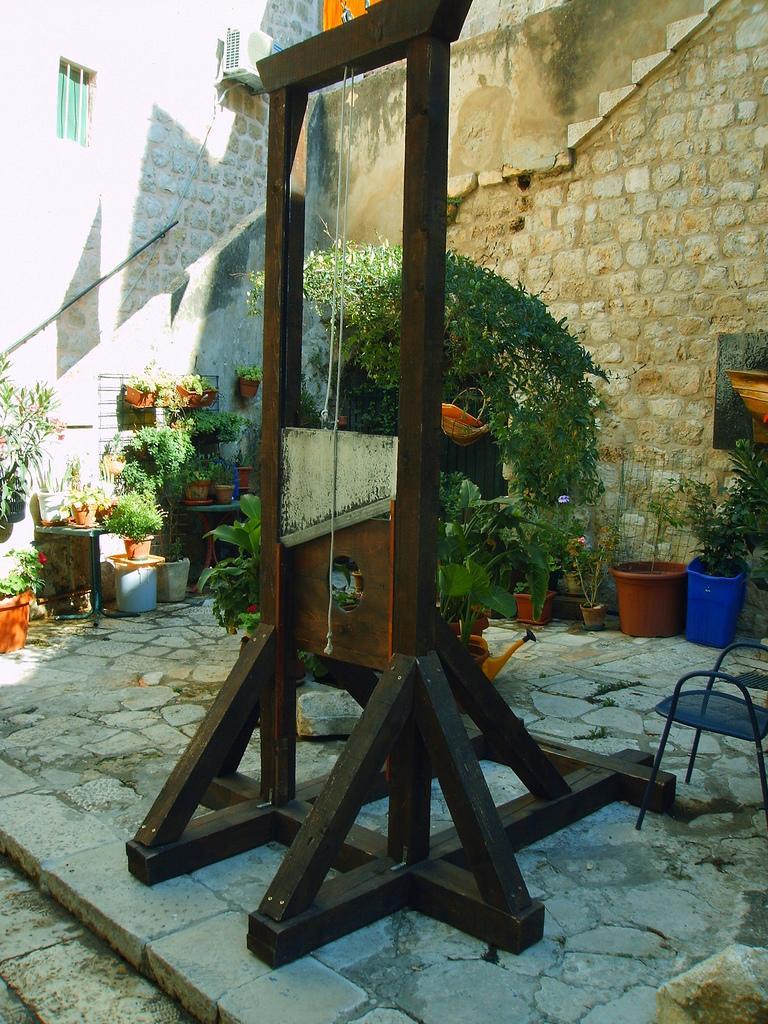Can you describe this image briefly? In this image there is a wooden object on the ground, there is a chair towards the right of the image, there are flower pots, there are plants, there is the wall, there is a window, there is a curtain, there is an object on the wall, there is a wire. 